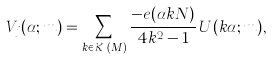Convert formula to latex. <formula><loc_0><loc_0><loc_500><loc_500>V _ { j } ( \alpha ; m ) = \sum _ { k \in \mathcal { K } _ { j } ( M ) } \frac { - e ( \alpha k N ) } { 4 k ^ { 2 } - 1 } \, U ( k \alpha ; m ) ,</formula> 